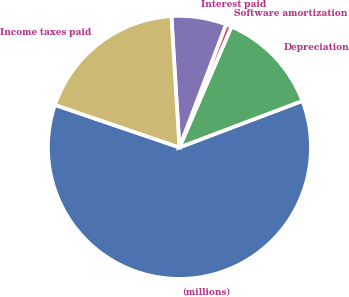Convert chart. <chart><loc_0><loc_0><loc_500><loc_500><pie_chart><fcel>(millions)<fcel>Depreciation<fcel>Software amortization<fcel>Interest paid<fcel>Income taxes paid<nl><fcel>60.98%<fcel>12.77%<fcel>0.71%<fcel>6.74%<fcel>18.79%<nl></chart> 